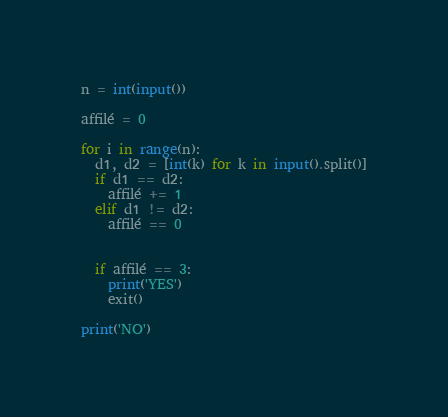<code> <loc_0><loc_0><loc_500><loc_500><_Python_>n = int(input())

affilé = 0

for i in range(n):
  d1, d2 = [int(k) for k in input().split()]
  if d1 == d2:
    affilé += 1
  elif d1 != d2:
    affilé == 0
  

  if affilé == 3:
    print('YES')
    exit()

print('NO')
</code> 